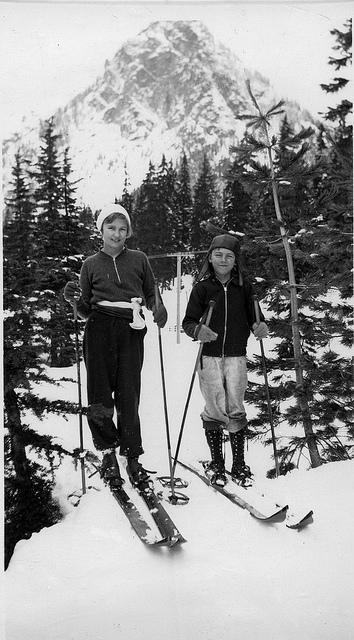What are the people doing?
Concise answer only. Skiing. What season is it in this picture?
Keep it brief. Winter. Are these men racing each other?
Write a very short answer. No. Are the people mobile?
Quick response, please. Yes. 